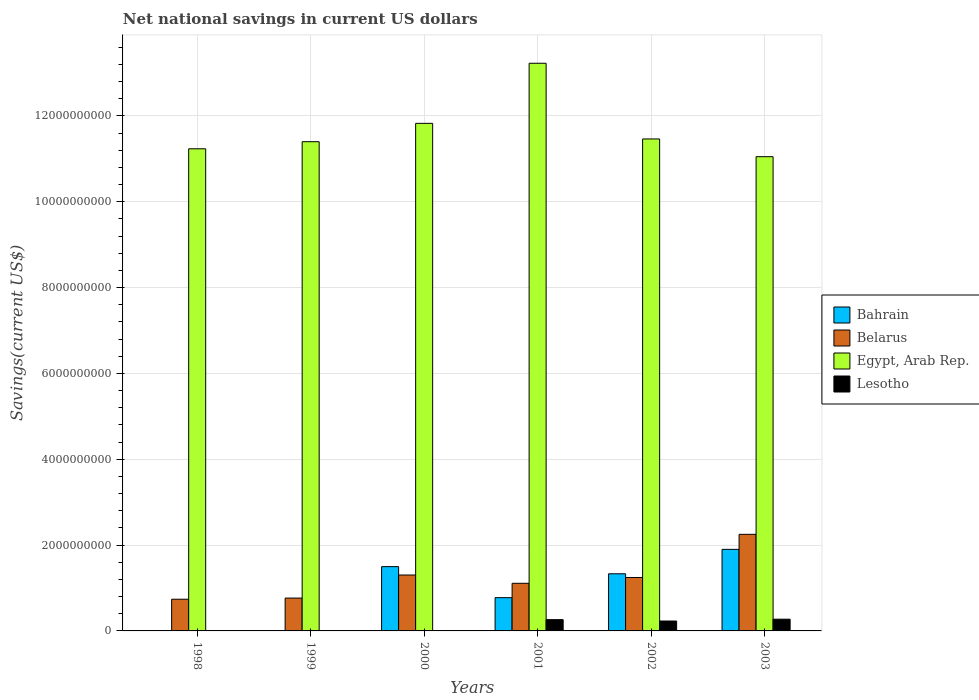How many different coloured bars are there?
Your response must be concise. 4. How many groups of bars are there?
Offer a very short reply. 6. Are the number of bars on each tick of the X-axis equal?
Ensure brevity in your answer.  No. How many bars are there on the 3rd tick from the left?
Your answer should be very brief. 3. How many bars are there on the 2nd tick from the right?
Your answer should be compact. 4. What is the net national savings in Belarus in 2001?
Your answer should be compact. 1.11e+09. Across all years, what is the maximum net national savings in Belarus?
Your response must be concise. 2.25e+09. Across all years, what is the minimum net national savings in Belarus?
Provide a succinct answer. 7.38e+08. What is the total net national savings in Bahrain in the graph?
Keep it short and to the point. 5.51e+09. What is the difference between the net national savings in Belarus in 2001 and that in 2002?
Keep it short and to the point. -1.35e+08. What is the difference between the net national savings in Belarus in 2000 and the net national savings in Bahrain in 2002?
Provide a short and direct response. -2.85e+07. What is the average net national savings in Lesotho per year?
Offer a very short reply. 1.28e+08. In the year 2000, what is the difference between the net national savings in Bahrain and net national savings in Belarus?
Give a very brief answer. 1.95e+08. What is the ratio of the net national savings in Belarus in 1999 to that in 2000?
Provide a succinct answer. 0.59. Is the net national savings in Lesotho in 2001 less than that in 2002?
Provide a succinct answer. No. What is the difference between the highest and the second highest net national savings in Belarus?
Provide a succinct answer. 9.48e+08. What is the difference between the highest and the lowest net national savings in Lesotho?
Provide a succinct answer. 2.73e+08. Is it the case that in every year, the sum of the net national savings in Egypt, Arab Rep. and net national savings in Bahrain is greater than the net national savings in Lesotho?
Keep it short and to the point. Yes. How many bars are there?
Offer a very short reply. 19. What is the difference between two consecutive major ticks on the Y-axis?
Give a very brief answer. 2.00e+09. Are the values on the major ticks of Y-axis written in scientific E-notation?
Your answer should be very brief. No. Does the graph contain any zero values?
Offer a very short reply. Yes. How are the legend labels stacked?
Offer a very short reply. Vertical. What is the title of the graph?
Offer a very short reply. Net national savings in current US dollars. What is the label or title of the X-axis?
Your answer should be compact. Years. What is the label or title of the Y-axis?
Ensure brevity in your answer.  Savings(current US$). What is the Savings(current US$) in Bahrain in 1998?
Keep it short and to the point. 0. What is the Savings(current US$) in Belarus in 1998?
Offer a very short reply. 7.38e+08. What is the Savings(current US$) in Egypt, Arab Rep. in 1998?
Keep it short and to the point. 1.12e+1. What is the Savings(current US$) of Lesotho in 1998?
Give a very brief answer. 0. What is the Savings(current US$) in Belarus in 1999?
Your response must be concise. 7.66e+08. What is the Savings(current US$) of Egypt, Arab Rep. in 1999?
Offer a very short reply. 1.14e+1. What is the Savings(current US$) in Lesotho in 1999?
Offer a very short reply. 0. What is the Savings(current US$) of Bahrain in 2000?
Keep it short and to the point. 1.50e+09. What is the Savings(current US$) of Belarus in 2000?
Your response must be concise. 1.30e+09. What is the Savings(current US$) in Egypt, Arab Rep. in 2000?
Your response must be concise. 1.18e+1. What is the Savings(current US$) in Lesotho in 2000?
Your answer should be very brief. 0. What is the Savings(current US$) of Bahrain in 2001?
Your response must be concise. 7.75e+08. What is the Savings(current US$) of Belarus in 2001?
Make the answer very short. 1.11e+09. What is the Savings(current US$) in Egypt, Arab Rep. in 2001?
Make the answer very short. 1.32e+1. What is the Savings(current US$) in Lesotho in 2001?
Your answer should be very brief. 2.63e+08. What is the Savings(current US$) in Bahrain in 2002?
Give a very brief answer. 1.33e+09. What is the Savings(current US$) of Belarus in 2002?
Your answer should be compact. 1.25e+09. What is the Savings(current US$) of Egypt, Arab Rep. in 2002?
Offer a very short reply. 1.15e+1. What is the Savings(current US$) of Lesotho in 2002?
Provide a short and direct response. 2.31e+08. What is the Savings(current US$) of Bahrain in 2003?
Give a very brief answer. 1.90e+09. What is the Savings(current US$) of Belarus in 2003?
Provide a short and direct response. 2.25e+09. What is the Savings(current US$) of Egypt, Arab Rep. in 2003?
Make the answer very short. 1.11e+1. What is the Savings(current US$) in Lesotho in 2003?
Provide a short and direct response. 2.73e+08. Across all years, what is the maximum Savings(current US$) in Bahrain?
Your answer should be very brief. 1.90e+09. Across all years, what is the maximum Savings(current US$) of Belarus?
Offer a terse response. 2.25e+09. Across all years, what is the maximum Savings(current US$) of Egypt, Arab Rep.?
Ensure brevity in your answer.  1.32e+1. Across all years, what is the maximum Savings(current US$) in Lesotho?
Offer a terse response. 2.73e+08. Across all years, what is the minimum Savings(current US$) in Belarus?
Provide a short and direct response. 7.38e+08. Across all years, what is the minimum Savings(current US$) in Egypt, Arab Rep.?
Offer a terse response. 1.11e+1. Across all years, what is the minimum Savings(current US$) in Lesotho?
Offer a terse response. 0. What is the total Savings(current US$) of Bahrain in the graph?
Your answer should be very brief. 5.51e+09. What is the total Savings(current US$) of Belarus in the graph?
Your answer should be very brief. 7.41e+09. What is the total Savings(current US$) in Egypt, Arab Rep. in the graph?
Your answer should be very brief. 7.02e+1. What is the total Savings(current US$) in Lesotho in the graph?
Make the answer very short. 7.67e+08. What is the difference between the Savings(current US$) in Belarus in 1998 and that in 1999?
Keep it short and to the point. -2.71e+07. What is the difference between the Savings(current US$) of Egypt, Arab Rep. in 1998 and that in 1999?
Keep it short and to the point. -1.66e+08. What is the difference between the Savings(current US$) in Belarus in 1998 and that in 2000?
Provide a short and direct response. -5.65e+08. What is the difference between the Savings(current US$) of Egypt, Arab Rep. in 1998 and that in 2000?
Make the answer very short. -5.93e+08. What is the difference between the Savings(current US$) of Belarus in 1998 and that in 2001?
Provide a succinct answer. -3.72e+08. What is the difference between the Savings(current US$) in Egypt, Arab Rep. in 1998 and that in 2001?
Keep it short and to the point. -1.99e+09. What is the difference between the Savings(current US$) in Belarus in 1998 and that in 2002?
Give a very brief answer. -5.07e+08. What is the difference between the Savings(current US$) in Egypt, Arab Rep. in 1998 and that in 2002?
Your answer should be compact. -2.29e+08. What is the difference between the Savings(current US$) of Belarus in 1998 and that in 2003?
Offer a terse response. -1.51e+09. What is the difference between the Savings(current US$) of Egypt, Arab Rep. in 1998 and that in 2003?
Your answer should be very brief. 1.84e+08. What is the difference between the Savings(current US$) in Belarus in 1999 and that in 2000?
Provide a short and direct response. -5.37e+08. What is the difference between the Savings(current US$) of Egypt, Arab Rep. in 1999 and that in 2000?
Ensure brevity in your answer.  -4.27e+08. What is the difference between the Savings(current US$) in Belarus in 1999 and that in 2001?
Offer a terse response. -3.45e+08. What is the difference between the Savings(current US$) in Egypt, Arab Rep. in 1999 and that in 2001?
Offer a very short reply. -1.83e+09. What is the difference between the Savings(current US$) in Belarus in 1999 and that in 2002?
Your response must be concise. -4.80e+08. What is the difference between the Savings(current US$) in Egypt, Arab Rep. in 1999 and that in 2002?
Offer a very short reply. -6.37e+07. What is the difference between the Savings(current US$) of Belarus in 1999 and that in 2003?
Keep it short and to the point. -1.49e+09. What is the difference between the Savings(current US$) in Egypt, Arab Rep. in 1999 and that in 2003?
Offer a terse response. 3.50e+08. What is the difference between the Savings(current US$) in Bahrain in 2000 and that in 2001?
Give a very brief answer. 7.23e+08. What is the difference between the Savings(current US$) in Belarus in 2000 and that in 2001?
Offer a terse response. 1.93e+08. What is the difference between the Savings(current US$) in Egypt, Arab Rep. in 2000 and that in 2001?
Offer a very short reply. -1.40e+09. What is the difference between the Savings(current US$) in Bahrain in 2000 and that in 2002?
Give a very brief answer. 1.67e+08. What is the difference between the Savings(current US$) in Belarus in 2000 and that in 2002?
Your answer should be very brief. 5.77e+07. What is the difference between the Savings(current US$) in Egypt, Arab Rep. in 2000 and that in 2002?
Ensure brevity in your answer.  3.64e+08. What is the difference between the Savings(current US$) of Bahrain in 2000 and that in 2003?
Offer a very short reply. -4.02e+08. What is the difference between the Savings(current US$) in Belarus in 2000 and that in 2003?
Make the answer very short. -9.48e+08. What is the difference between the Savings(current US$) in Egypt, Arab Rep. in 2000 and that in 2003?
Your response must be concise. 7.77e+08. What is the difference between the Savings(current US$) in Bahrain in 2001 and that in 2002?
Give a very brief answer. -5.56e+08. What is the difference between the Savings(current US$) of Belarus in 2001 and that in 2002?
Keep it short and to the point. -1.35e+08. What is the difference between the Savings(current US$) in Egypt, Arab Rep. in 2001 and that in 2002?
Offer a very short reply. 1.76e+09. What is the difference between the Savings(current US$) in Lesotho in 2001 and that in 2002?
Make the answer very short. 3.17e+07. What is the difference between the Savings(current US$) of Bahrain in 2001 and that in 2003?
Make the answer very short. -1.13e+09. What is the difference between the Savings(current US$) of Belarus in 2001 and that in 2003?
Keep it short and to the point. -1.14e+09. What is the difference between the Savings(current US$) in Egypt, Arab Rep. in 2001 and that in 2003?
Give a very brief answer. 2.18e+09. What is the difference between the Savings(current US$) in Lesotho in 2001 and that in 2003?
Keep it short and to the point. -1.07e+07. What is the difference between the Savings(current US$) in Bahrain in 2002 and that in 2003?
Provide a short and direct response. -5.69e+08. What is the difference between the Savings(current US$) in Belarus in 2002 and that in 2003?
Make the answer very short. -1.01e+09. What is the difference between the Savings(current US$) in Egypt, Arab Rep. in 2002 and that in 2003?
Provide a short and direct response. 4.14e+08. What is the difference between the Savings(current US$) in Lesotho in 2002 and that in 2003?
Provide a short and direct response. -4.24e+07. What is the difference between the Savings(current US$) of Belarus in 1998 and the Savings(current US$) of Egypt, Arab Rep. in 1999?
Your response must be concise. -1.07e+1. What is the difference between the Savings(current US$) in Belarus in 1998 and the Savings(current US$) in Egypt, Arab Rep. in 2000?
Provide a short and direct response. -1.11e+1. What is the difference between the Savings(current US$) of Belarus in 1998 and the Savings(current US$) of Egypt, Arab Rep. in 2001?
Offer a terse response. -1.25e+1. What is the difference between the Savings(current US$) of Belarus in 1998 and the Savings(current US$) of Lesotho in 2001?
Give a very brief answer. 4.76e+08. What is the difference between the Savings(current US$) in Egypt, Arab Rep. in 1998 and the Savings(current US$) in Lesotho in 2001?
Give a very brief answer. 1.10e+1. What is the difference between the Savings(current US$) in Belarus in 1998 and the Savings(current US$) in Egypt, Arab Rep. in 2002?
Your answer should be compact. -1.07e+1. What is the difference between the Savings(current US$) of Belarus in 1998 and the Savings(current US$) of Lesotho in 2002?
Make the answer very short. 5.07e+08. What is the difference between the Savings(current US$) of Egypt, Arab Rep. in 1998 and the Savings(current US$) of Lesotho in 2002?
Give a very brief answer. 1.10e+1. What is the difference between the Savings(current US$) in Belarus in 1998 and the Savings(current US$) in Egypt, Arab Rep. in 2003?
Keep it short and to the point. -1.03e+1. What is the difference between the Savings(current US$) in Belarus in 1998 and the Savings(current US$) in Lesotho in 2003?
Ensure brevity in your answer.  4.65e+08. What is the difference between the Savings(current US$) of Egypt, Arab Rep. in 1998 and the Savings(current US$) of Lesotho in 2003?
Offer a very short reply. 1.10e+1. What is the difference between the Savings(current US$) of Belarus in 1999 and the Savings(current US$) of Egypt, Arab Rep. in 2000?
Your response must be concise. -1.11e+1. What is the difference between the Savings(current US$) of Belarus in 1999 and the Savings(current US$) of Egypt, Arab Rep. in 2001?
Give a very brief answer. -1.25e+1. What is the difference between the Savings(current US$) of Belarus in 1999 and the Savings(current US$) of Lesotho in 2001?
Your answer should be compact. 5.03e+08. What is the difference between the Savings(current US$) of Egypt, Arab Rep. in 1999 and the Savings(current US$) of Lesotho in 2001?
Give a very brief answer. 1.11e+1. What is the difference between the Savings(current US$) in Belarus in 1999 and the Savings(current US$) in Egypt, Arab Rep. in 2002?
Give a very brief answer. -1.07e+1. What is the difference between the Savings(current US$) in Belarus in 1999 and the Savings(current US$) in Lesotho in 2002?
Provide a short and direct response. 5.35e+08. What is the difference between the Savings(current US$) in Egypt, Arab Rep. in 1999 and the Savings(current US$) in Lesotho in 2002?
Keep it short and to the point. 1.12e+1. What is the difference between the Savings(current US$) of Belarus in 1999 and the Savings(current US$) of Egypt, Arab Rep. in 2003?
Provide a short and direct response. -1.03e+1. What is the difference between the Savings(current US$) of Belarus in 1999 and the Savings(current US$) of Lesotho in 2003?
Provide a short and direct response. 4.92e+08. What is the difference between the Savings(current US$) of Egypt, Arab Rep. in 1999 and the Savings(current US$) of Lesotho in 2003?
Give a very brief answer. 1.11e+1. What is the difference between the Savings(current US$) in Bahrain in 2000 and the Savings(current US$) in Belarus in 2001?
Ensure brevity in your answer.  3.88e+08. What is the difference between the Savings(current US$) in Bahrain in 2000 and the Savings(current US$) in Egypt, Arab Rep. in 2001?
Give a very brief answer. -1.17e+1. What is the difference between the Savings(current US$) in Bahrain in 2000 and the Savings(current US$) in Lesotho in 2001?
Your answer should be compact. 1.24e+09. What is the difference between the Savings(current US$) of Belarus in 2000 and the Savings(current US$) of Egypt, Arab Rep. in 2001?
Offer a very short reply. -1.19e+1. What is the difference between the Savings(current US$) of Belarus in 2000 and the Savings(current US$) of Lesotho in 2001?
Keep it short and to the point. 1.04e+09. What is the difference between the Savings(current US$) in Egypt, Arab Rep. in 2000 and the Savings(current US$) in Lesotho in 2001?
Your answer should be very brief. 1.16e+1. What is the difference between the Savings(current US$) of Bahrain in 2000 and the Savings(current US$) of Belarus in 2002?
Offer a very short reply. 2.53e+08. What is the difference between the Savings(current US$) of Bahrain in 2000 and the Savings(current US$) of Egypt, Arab Rep. in 2002?
Make the answer very short. -9.97e+09. What is the difference between the Savings(current US$) of Bahrain in 2000 and the Savings(current US$) of Lesotho in 2002?
Keep it short and to the point. 1.27e+09. What is the difference between the Savings(current US$) of Belarus in 2000 and the Savings(current US$) of Egypt, Arab Rep. in 2002?
Offer a terse response. -1.02e+1. What is the difference between the Savings(current US$) in Belarus in 2000 and the Savings(current US$) in Lesotho in 2002?
Provide a short and direct response. 1.07e+09. What is the difference between the Savings(current US$) of Egypt, Arab Rep. in 2000 and the Savings(current US$) of Lesotho in 2002?
Offer a terse response. 1.16e+1. What is the difference between the Savings(current US$) of Bahrain in 2000 and the Savings(current US$) of Belarus in 2003?
Your answer should be very brief. -7.53e+08. What is the difference between the Savings(current US$) in Bahrain in 2000 and the Savings(current US$) in Egypt, Arab Rep. in 2003?
Give a very brief answer. -9.55e+09. What is the difference between the Savings(current US$) of Bahrain in 2000 and the Savings(current US$) of Lesotho in 2003?
Ensure brevity in your answer.  1.22e+09. What is the difference between the Savings(current US$) in Belarus in 2000 and the Savings(current US$) in Egypt, Arab Rep. in 2003?
Your answer should be compact. -9.75e+09. What is the difference between the Savings(current US$) in Belarus in 2000 and the Savings(current US$) in Lesotho in 2003?
Provide a succinct answer. 1.03e+09. What is the difference between the Savings(current US$) in Egypt, Arab Rep. in 2000 and the Savings(current US$) in Lesotho in 2003?
Your answer should be very brief. 1.16e+1. What is the difference between the Savings(current US$) in Bahrain in 2001 and the Savings(current US$) in Belarus in 2002?
Give a very brief answer. -4.70e+08. What is the difference between the Savings(current US$) of Bahrain in 2001 and the Savings(current US$) of Egypt, Arab Rep. in 2002?
Provide a succinct answer. -1.07e+1. What is the difference between the Savings(current US$) of Bahrain in 2001 and the Savings(current US$) of Lesotho in 2002?
Your response must be concise. 5.44e+08. What is the difference between the Savings(current US$) in Belarus in 2001 and the Savings(current US$) in Egypt, Arab Rep. in 2002?
Offer a very short reply. -1.04e+1. What is the difference between the Savings(current US$) of Belarus in 2001 and the Savings(current US$) of Lesotho in 2002?
Your answer should be compact. 8.79e+08. What is the difference between the Savings(current US$) of Egypt, Arab Rep. in 2001 and the Savings(current US$) of Lesotho in 2002?
Make the answer very short. 1.30e+1. What is the difference between the Savings(current US$) of Bahrain in 2001 and the Savings(current US$) of Belarus in 2003?
Keep it short and to the point. -1.48e+09. What is the difference between the Savings(current US$) in Bahrain in 2001 and the Savings(current US$) in Egypt, Arab Rep. in 2003?
Keep it short and to the point. -1.03e+1. What is the difference between the Savings(current US$) of Bahrain in 2001 and the Savings(current US$) of Lesotho in 2003?
Your answer should be compact. 5.02e+08. What is the difference between the Savings(current US$) of Belarus in 2001 and the Savings(current US$) of Egypt, Arab Rep. in 2003?
Offer a terse response. -9.94e+09. What is the difference between the Savings(current US$) in Belarus in 2001 and the Savings(current US$) in Lesotho in 2003?
Your response must be concise. 8.37e+08. What is the difference between the Savings(current US$) of Egypt, Arab Rep. in 2001 and the Savings(current US$) of Lesotho in 2003?
Make the answer very short. 1.30e+1. What is the difference between the Savings(current US$) in Bahrain in 2002 and the Savings(current US$) in Belarus in 2003?
Your answer should be very brief. -9.19e+08. What is the difference between the Savings(current US$) of Bahrain in 2002 and the Savings(current US$) of Egypt, Arab Rep. in 2003?
Keep it short and to the point. -9.72e+09. What is the difference between the Savings(current US$) of Bahrain in 2002 and the Savings(current US$) of Lesotho in 2003?
Keep it short and to the point. 1.06e+09. What is the difference between the Savings(current US$) in Belarus in 2002 and the Savings(current US$) in Egypt, Arab Rep. in 2003?
Give a very brief answer. -9.81e+09. What is the difference between the Savings(current US$) of Belarus in 2002 and the Savings(current US$) of Lesotho in 2003?
Provide a succinct answer. 9.72e+08. What is the difference between the Savings(current US$) in Egypt, Arab Rep. in 2002 and the Savings(current US$) in Lesotho in 2003?
Your response must be concise. 1.12e+1. What is the average Savings(current US$) of Bahrain per year?
Your answer should be compact. 9.18e+08. What is the average Savings(current US$) of Belarus per year?
Offer a terse response. 1.24e+09. What is the average Savings(current US$) in Egypt, Arab Rep. per year?
Offer a terse response. 1.17e+1. What is the average Savings(current US$) of Lesotho per year?
Ensure brevity in your answer.  1.28e+08. In the year 1998, what is the difference between the Savings(current US$) of Belarus and Savings(current US$) of Egypt, Arab Rep.?
Offer a very short reply. -1.05e+1. In the year 1999, what is the difference between the Savings(current US$) in Belarus and Savings(current US$) in Egypt, Arab Rep.?
Give a very brief answer. -1.06e+1. In the year 2000, what is the difference between the Savings(current US$) in Bahrain and Savings(current US$) in Belarus?
Offer a very short reply. 1.95e+08. In the year 2000, what is the difference between the Savings(current US$) in Bahrain and Savings(current US$) in Egypt, Arab Rep.?
Your response must be concise. -1.03e+1. In the year 2000, what is the difference between the Savings(current US$) in Belarus and Savings(current US$) in Egypt, Arab Rep.?
Provide a succinct answer. -1.05e+1. In the year 2001, what is the difference between the Savings(current US$) in Bahrain and Savings(current US$) in Belarus?
Ensure brevity in your answer.  -3.35e+08. In the year 2001, what is the difference between the Savings(current US$) of Bahrain and Savings(current US$) of Egypt, Arab Rep.?
Your response must be concise. -1.25e+1. In the year 2001, what is the difference between the Savings(current US$) in Bahrain and Savings(current US$) in Lesotho?
Make the answer very short. 5.12e+08. In the year 2001, what is the difference between the Savings(current US$) of Belarus and Savings(current US$) of Egypt, Arab Rep.?
Offer a very short reply. -1.21e+1. In the year 2001, what is the difference between the Savings(current US$) in Belarus and Savings(current US$) in Lesotho?
Ensure brevity in your answer.  8.47e+08. In the year 2001, what is the difference between the Savings(current US$) in Egypt, Arab Rep. and Savings(current US$) in Lesotho?
Provide a succinct answer. 1.30e+1. In the year 2002, what is the difference between the Savings(current US$) of Bahrain and Savings(current US$) of Belarus?
Offer a very short reply. 8.63e+07. In the year 2002, what is the difference between the Savings(current US$) in Bahrain and Savings(current US$) in Egypt, Arab Rep.?
Provide a succinct answer. -1.01e+1. In the year 2002, what is the difference between the Savings(current US$) of Bahrain and Savings(current US$) of Lesotho?
Give a very brief answer. 1.10e+09. In the year 2002, what is the difference between the Savings(current US$) of Belarus and Savings(current US$) of Egypt, Arab Rep.?
Make the answer very short. -1.02e+1. In the year 2002, what is the difference between the Savings(current US$) in Belarus and Savings(current US$) in Lesotho?
Provide a short and direct response. 1.01e+09. In the year 2002, what is the difference between the Savings(current US$) of Egypt, Arab Rep. and Savings(current US$) of Lesotho?
Your answer should be compact. 1.12e+1. In the year 2003, what is the difference between the Savings(current US$) in Bahrain and Savings(current US$) in Belarus?
Your answer should be compact. -3.51e+08. In the year 2003, what is the difference between the Savings(current US$) of Bahrain and Savings(current US$) of Egypt, Arab Rep.?
Provide a succinct answer. -9.15e+09. In the year 2003, what is the difference between the Savings(current US$) in Bahrain and Savings(current US$) in Lesotho?
Your answer should be very brief. 1.63e+09. In the year 2003, what is the difference between the Savings(current US$) of Belarus and Savings(current US$) of Egypt, Arab Rep.?
Ensure brevity in your answer.  -8.80e+09. In the year 2003, what is the difference between the Savings(current US$) in Belarus and Savings(current US$) in Lesotho?
Your answer should be very brief. 1.98e+09. In the year 2003, what is the difference between the Savings(current US$) in Egypt, Arab Rep. and Savings(current US$) in Lesotho?
Provide a succinct answer. 1.08e+1. What is the ratio of the Savings(current US$) of Belarus in 1998 to that in 1999?
Ensure brevity in your answer.  0.96. What is the ratio of the Savings(current US$) in Egypt, Arab Rep. in 1998 to that in 1999?
Offer a terse response. 0.99. What is the ratio of the Savings(current US$) of Belarus in 1998 to that in 2000?
Offer a terse response. 0.57. What is the ratio of the Savings(current US$) in Egypt, Arab Rep. in 1998 to that in 2000?
Your response must be concise. 0.95. What is the ratio of the Savings(current US$) in Belarus in 1998 to that in 2001?
Offer a terse response. 0.67. What is the ratio of the Savings(current US$) of Egypt, Arab Rep. in 1998 to that in 2001?
Provide a succinct answer. 0.85. What is the ratio of the Savings(current US$) of Belarus in 1998 to that in 2002?
Your answer should be compact. 0.59. What is the ratio of the Savings(current US$) in Belarus in 1998 to that in 2003?
Give a very brief answer. 0.33. What is the ratio of the Savings(current US$) in Egypt, Arab Rep. in 1998 to that in 2003?
Ensure brevity in your answer.  1.02. What is the ratio of the Savings(current US$) in Belarus in 1999 to that in 2000?
Make the answer very short. 0.59. What is the ratio of the Savings(current US$) in Egypt, Arab Rep. in 1999 to that in 2000?
Your answer should be compact. 0.96. What is the ratio of the Savings(current US$) in Belarus in 1999 to that in 2001?
Make the answer very short. 0.69. What is the ratio of the Savings(current US$) of Egypt, Arab Rep. in 1999 to that in 2001?
Your answer should be compact. 0.86. What is the ratio of the Savings(current US$) in Belarus in 1999 to that in 2002?
Offer a terse response. 0.61. What is the ratio of the Savings(current US$) in Egypt, Arab Rep. in 1999 to that in 2002?
Your answer should be compact. 0.99. What is the ratio of the Savings(current US$) of Belarus in 1999 to that in 2003?
Keep it short and to the point. 0.34. What is the ratio of the Savings(current US$) of Egypt, Arab Rep. in 1999 to that in 2003?
Give a very brief answer. 1.03. What is the ratio of the Savings(current US$) of Bahrain in 2000 to that in 2001?
Provide a succinct answer. 1.93. What is the ratio of the Savings(current US$) of Belarus in 2000 to that in 2001?
Make the answer very short. 1.17. What is the ratio of the Savings(current US$) in Egypt, Arab Rep. in 2000 to that in 2001?
Offer a very short reply. 0.89. What is the ratio of the Savings(current US$) of Bahrain in 2000 to that in 2002?
Keep it short and to the point. 1.13. What is the ratio of the Savings(current US$) of Belarus in 2000 to that in 2002?
Keep it short and to the point. 1.05. What is the ratio of the Savings(current US$) in Egypt, Arab Rep. in 2000 to that in 2002?
Your response must be concise. 1.03. What is the ratio of the Savings(current US$) in Bahrain in 2000 to that in 2003?
Offer a very short reply. 0.79. What is the ratio of the Savings(current US$) of Belarus in 2000 to that in 2003?
Provide a succinct answer. 0.58. What is the ratio of the Savings(current US$) in Egypt, Arab Rep. in 2000 to that in 2003?
Offer a terse response. 1.07. What is the ratio of the Savings(current US$) in Bahrain in 2001 to that in 2002?
Provide a succinct answer. 0.58. What is the ratio of the Savings(current US$) in Belarus in 2001 to that in 2002?
Ensure brevity in your answer.  0.89. What is the ratio of the Savings(current US$) in Egypt, Arab Rep. in 2001 to that in 2002?
Offer a very short reply. 1.15. What is the ratio of the Savings(current US$) of Lesotho in 2001 to that in 2002?
Provide a succinct answer. 1.14. What is the ratio of the Savings(current US$) in Bahrain in 2001 to that in 2003?
Provide a succinct answer. 0.41. What is the ratio of the Savings(current US$) of Belarus in 2001 to that in 2003?
Provide a succinct answer. 0.49. What is the ratio of the Savings(current US$) in Egypt, Arab Rep. in 2001 to that in 2003?
Your response must be concise. 1.2. What is the ratio of the Savings(current US$) in Lesotho in 2001 to that in 2003?
Give a very brief answer. 0.96. What is the ratio of the Savings(current US$) in Bahrain in 2002 to that in 2003?
Your response must be concise. 0.7. What is the ratio of the Savings(current US$) of Belarus in 2002 to that in 2003?
Your response must be concise. 0.55. What is the ratio of the Savings(current US$) of Egypt, Arab Rep. in 2002 to that in 2003?
Give a very brief answer. 1.04. What is the ratio of the Savings(current US$) of Lesotho in 2002 to that in 2003?
Provide a succinct answer. 0.85. What is the difference between the highest and the second highest Savings(current US$) in Bahrain?
Your response must be concise. 4.02e+08. What is the difference between the highest and the second highest Savings(current US$) in Belarus?
Ensure brevity in your answer.  9.48e+08. What is the difference between the highest and the second highest Savings(current US$) of Egypt, Arab Rep.?
Provide a succinct answer. 1.40e+09. What is the difference between the highest and the second highest Savings(current US$) of Lesotho?
Offer a very short reply. 1.07e+07. What is the difference between the highest and the lowest Savings(current US$) in Bahrain?
Offer a terse response. 1.90e+09. What is the difference between the highest and the lowest Savings(current US$) of Belarus?
Provide a succinct answer. 1.51e+09. What is the difference between the highest and the lowest Savings(current US$) of Egypt, Arab Rep.?
Your answer should be very brief. 2.18e+09. What is the difference between the highest and the lowest Savings(current US$) in Lesotho?
Your answer should be compact. 2.73e+08. 